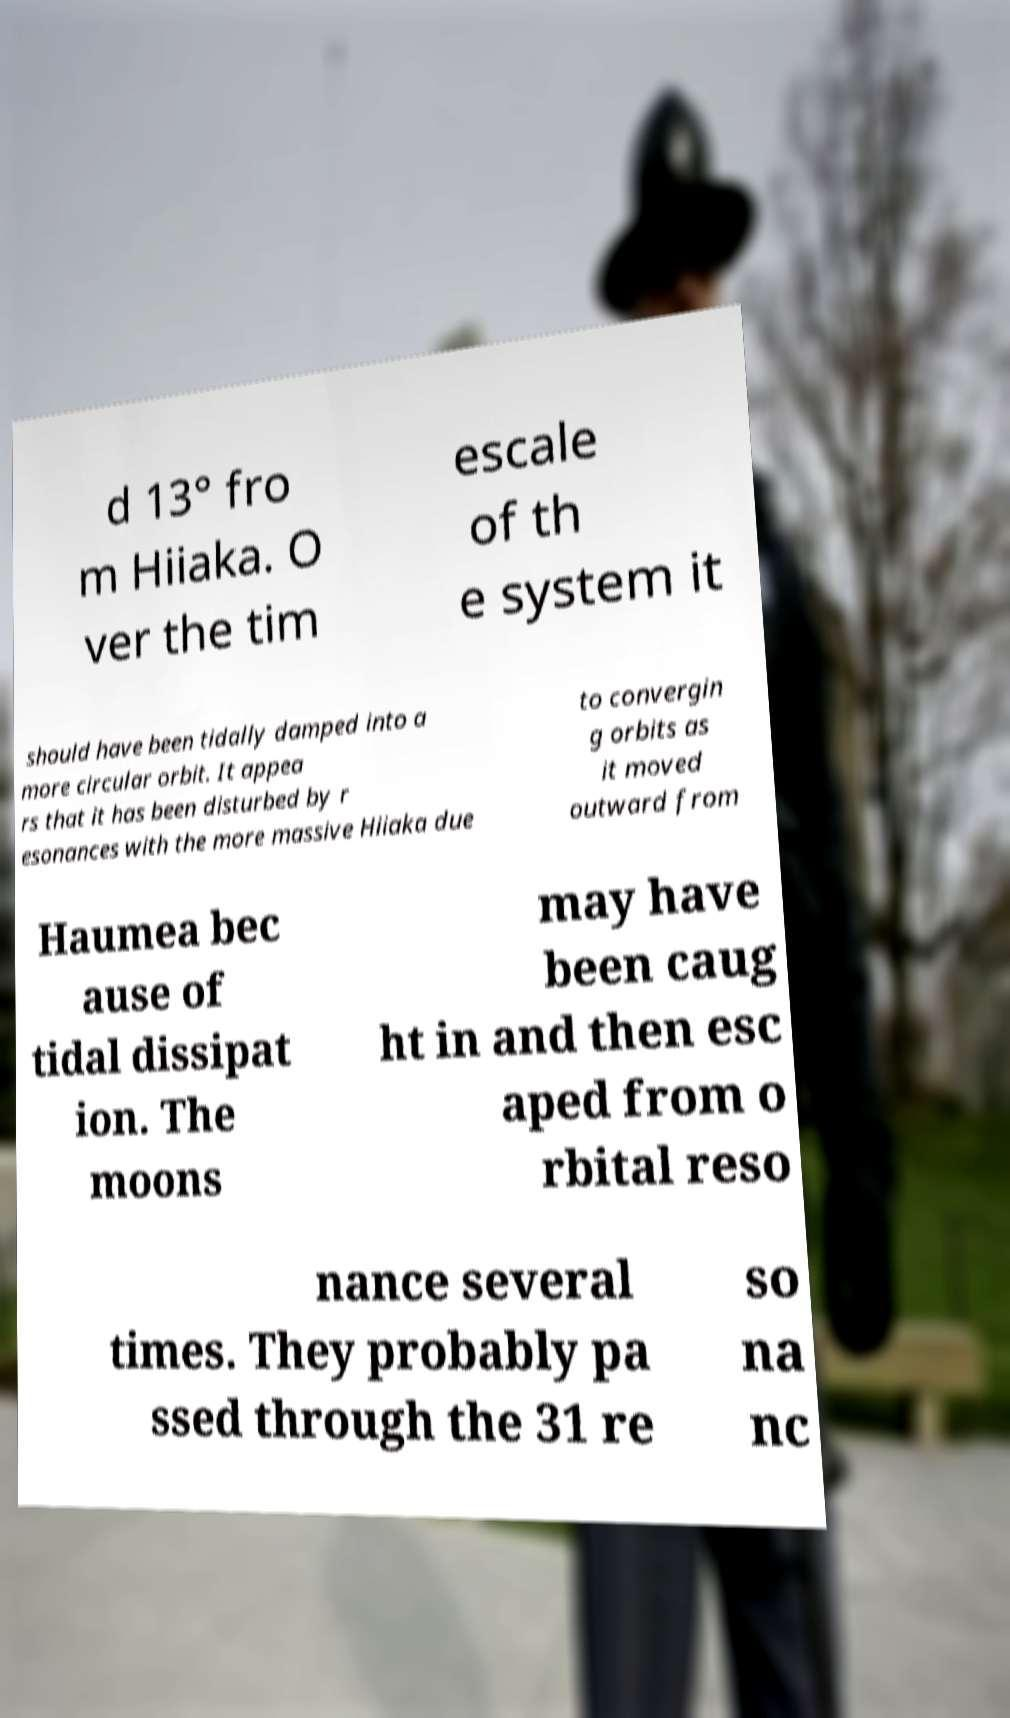Please identify and transcribe the text found in this image. d 13° fro m Hiiaka. O ver the tim escale of th e system it should have been tidally damped into a more circular orbit. It appea rs that it has been disturbed by r esonances with the more massive Hiiaka due to convergin g orbits as it moved outward from Haumea bec ause of tidal dissipat ion. The moons may have been caug ht in and then esc aped from o rbital reso nance several times. They probably pa ssed through the 31 re so na nc 